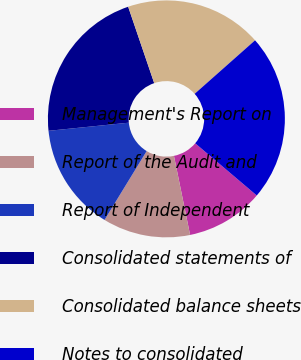<chart> <loc_0><loc_0><loc_500><loc_500><pie_chart><fcel>Management's Report on<fcel>Report of the Audit and<fcel>Report of Independent<fcel>Consolidated statements of<fcel>Consolidated balance sheets<fcel>Notes to consolidated<nl><fcel>10.6%<fcel>11.95%<fcel>14.65%<fcel>21.38%<fcel>18.69%<fcel>22.73%<nl></chart> 